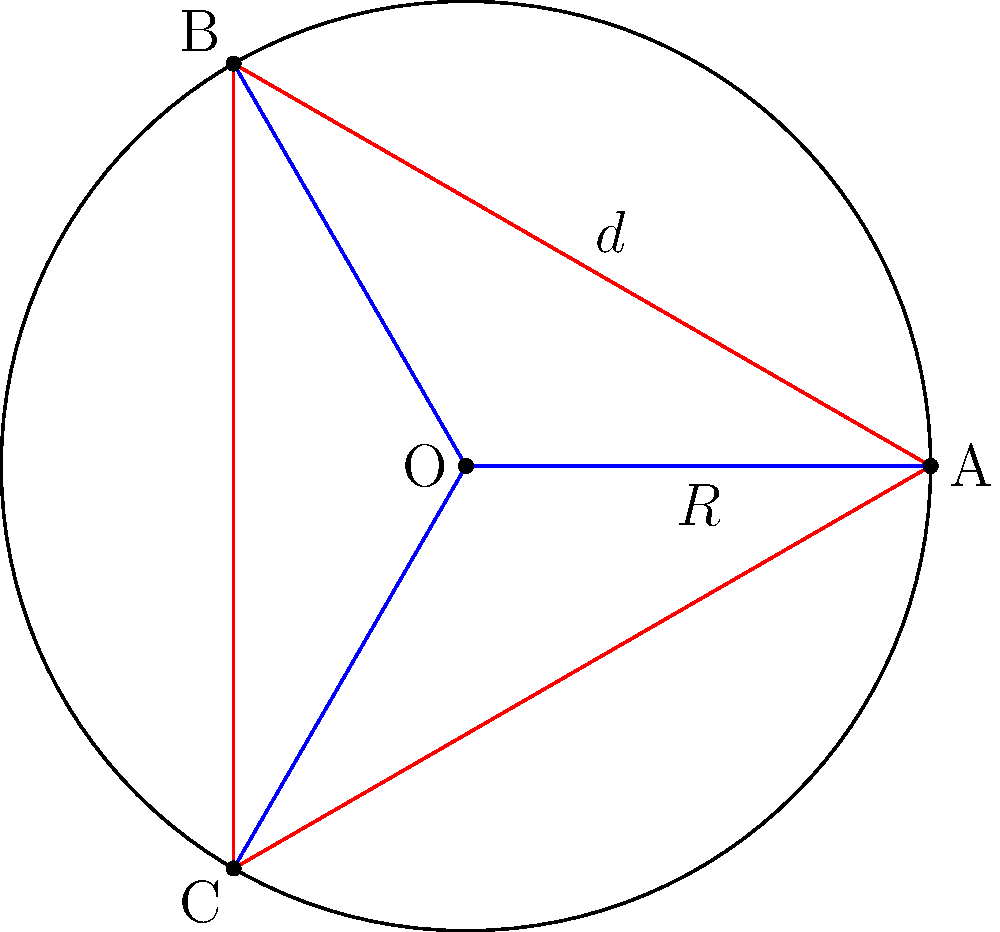In a circular binary star system, three stars A, B, and C are equally spaced around the circular orbit with radius $R = 2$ astronomical units (AU). If the separation distance between any two adjacent stars is $d$, what is the value of $d$ in AU? To solve this problem, we'll follow these steps:

1) The three stars form an equilateral triangle inscribed in the circle of the orbit.

2) The radius of the circle (R) is given as 2 AU.

3) In an equilateral triangle, the side length (d) is related to the radius of the circumscribed circle (R) by the formula:

   $$d = R\sqrt{3}$$

4) Substituting the given value of R:

   $$d = 2\sqrt{3}\ \text{AU}$$

5) To calculate the numerical value:
   
   $$d = 2 \times 1.732050808 \approx 3.464\ \text{AU}$$

Therefore, the separation distance between any two adjacent stars in this binary system is approximately 3.464 AU.
Answer: $2\sqrt{3}\ \text{AU}$ or $3.464\ \text{AU}$ 